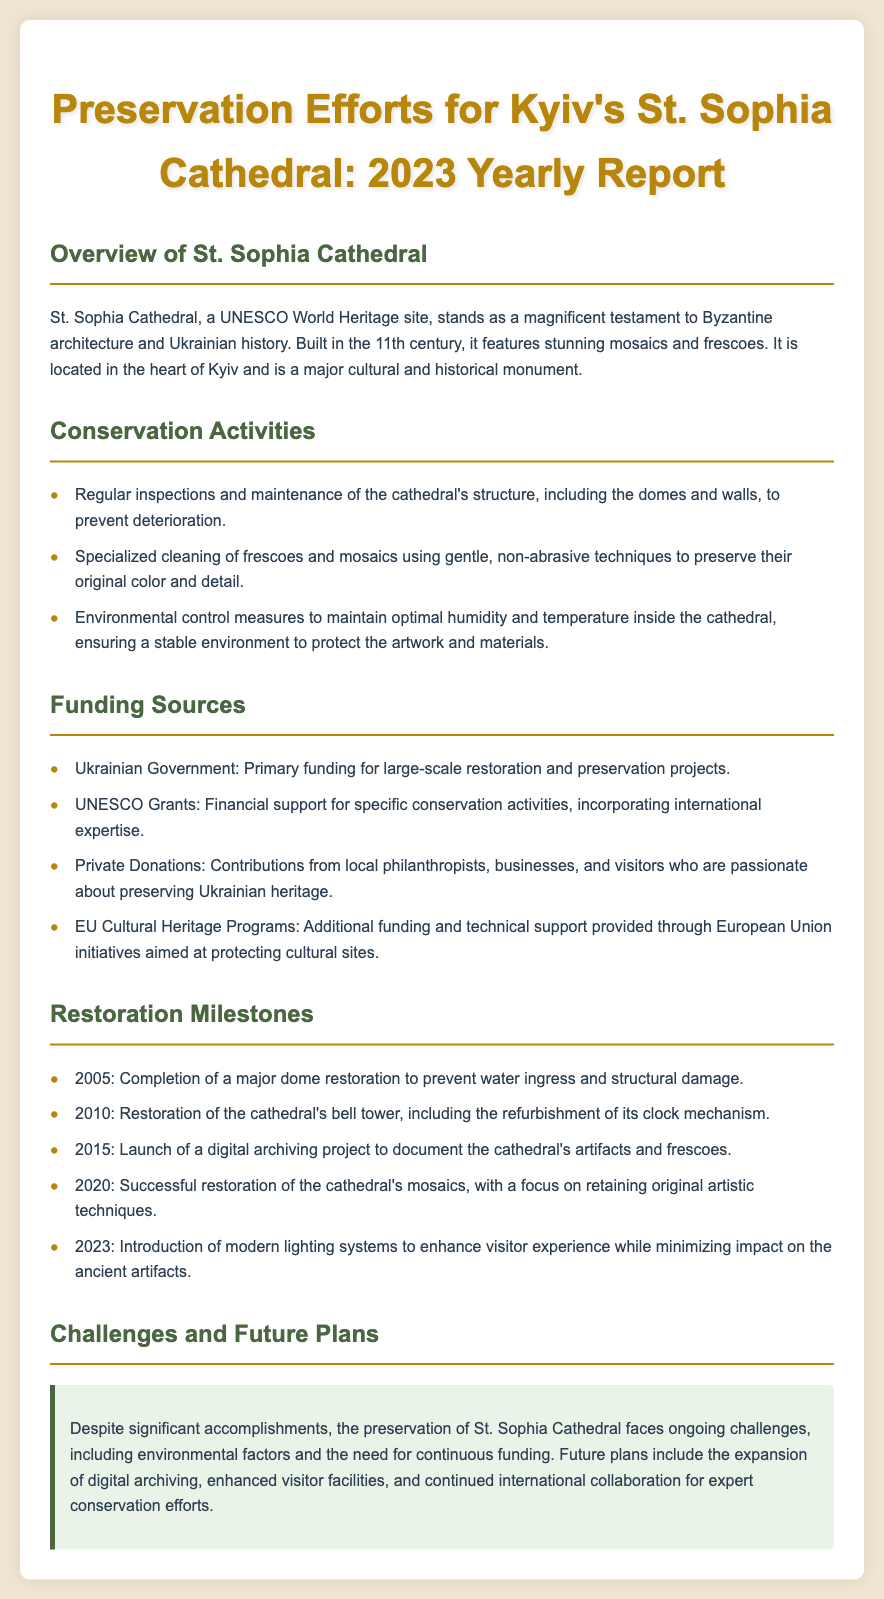What is St. Sophia Cathedral recognized as? St. Sophia Cathedral is recognized as a UNESCO World Heritage site, highlighted in the overview section of the document.
Answer: UNESCO World Heritage site When was St. Sophia Cathedral built? The document states that St. Sophia Cathedral was built in the 11th century, featured in the overview section.
Answer: 11th century What type of funding is provided for preservation by the Ukrainian Government? The document lists the Ukrainian Government as the primary funding source for large-scale restoration and preservation projects.
Answer: Primary funding What was completed in 2005? The restoration milestone in 2005 was the completion of a major dome restoration mentioned in the restoration milestones section.
Answer: Major dome restoration What is one challenge mentioned for the preservation efforts? The document highlights ongoing challenges, including environmental factors, which affect preservation efforts.
Answer: Environmental factors What modern addition was made in 2023? In 2023, the introduction of modern lighting systems was noted as an enhancement for visitor experience.
Answer: Modern lighting systems Which organization provides financial support for specific conservation activities? UNESCO Grants are mentioned as a source of financial support for specific conservation activities.
Answer: UNESCO Grants What restoration occurred in 2010? The document states that in 2010, the restoration of the cathedral's bell tower was completed.
Answer: Bell tower restoration 